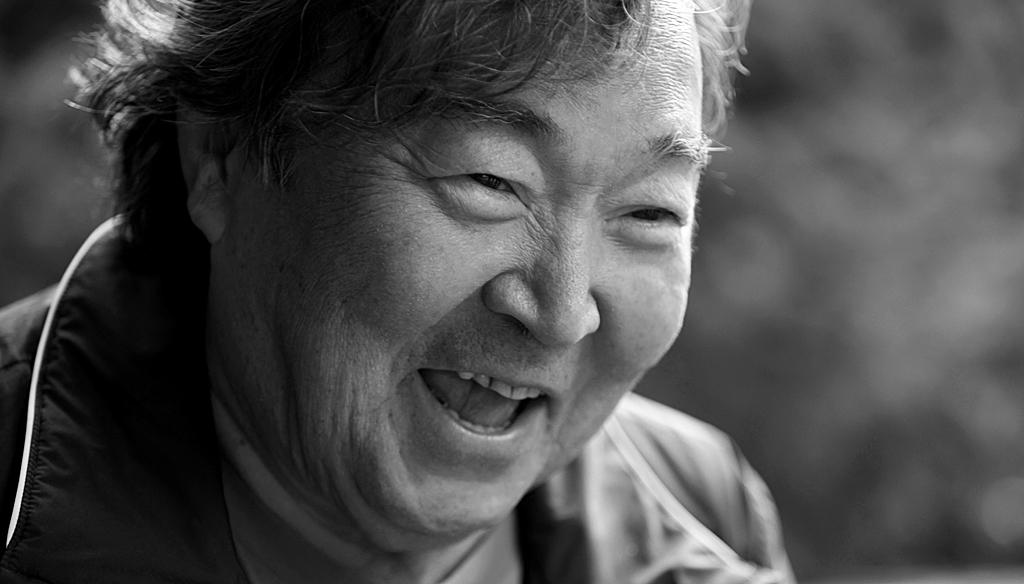What is the color scheme of the image? The image is black and white. Can you describe the main subject in the image? There is a person in the image. What is the person wearing? The person is wearing a shirt. How would you describe the background of the image? The background of the image is blurry. What type of yoke can be seen in the image? There is no yoke present in the image. How many ears does the person have in the image? The image is black and white, and it is not possible to determine the number of ears the person has based on the provided facts. 